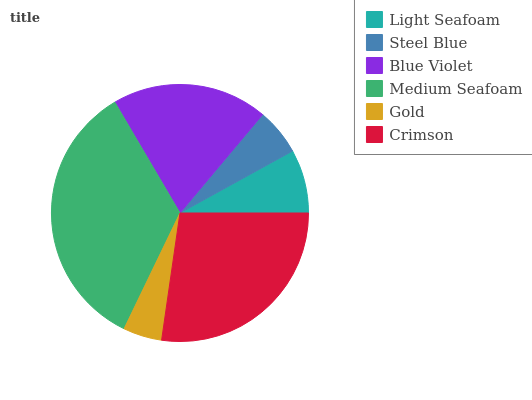Is Gold the minimum?
Answer yes or no. Yes. Is Medium Seafoam the maximum?
Answer yes or no. Yes. Is Steel Blue the minimum?
Answer yes or no. No. Is Steel Blue the maximum?
Answer yes or no. No. Is Light Seafoam greater than Steel Blue?
Answer yes or no. Yes. Is Steel Blue less than Light Seafoam?
Answer yes or no. Yes. Is Steel Blue greater than Light Seafoam?
Answer yes or no. No. Is Light Seafoam less than Steel Blue?
Answer yes or no. No. Is Blue Violet the high median?
Answer yes or no. Yes. Is Light Seafoam the low median?
Answer yes or no. Yes. Is Gold the high median?
Answer yes or no. No. Is Blue Violet the low median?
Answer yes or no. No. 